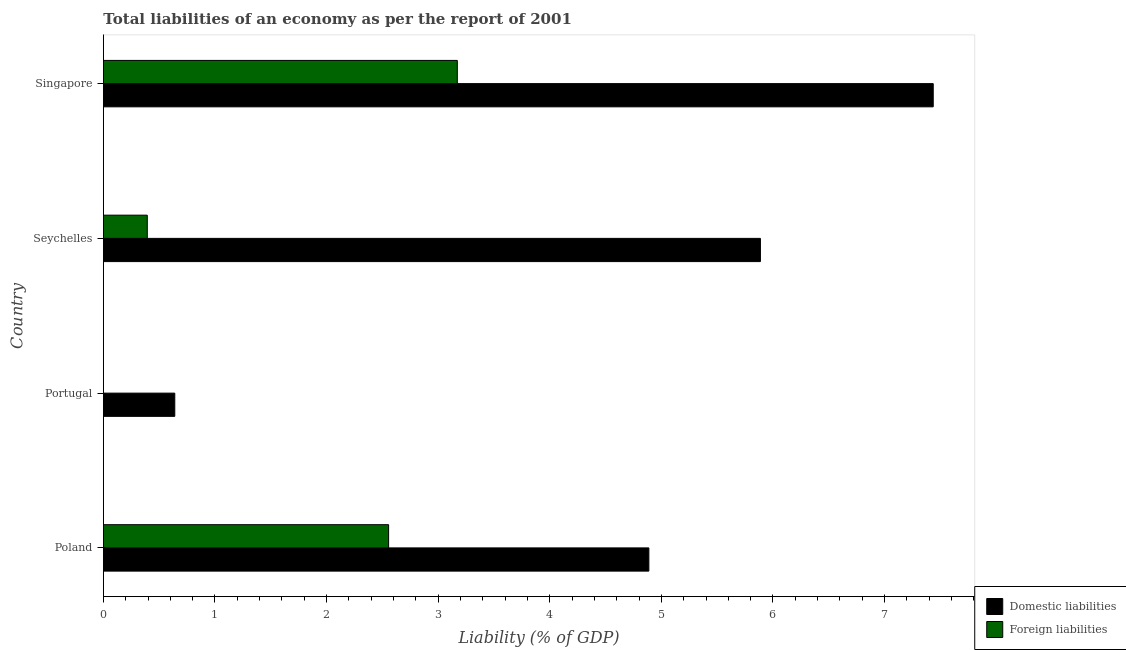How many different coloured bars are there?
Your answer should be compact. 2. How many bars are there on the 2nd tick from the top?
Your answer should be compact. 2. How many bars are there on the 1st tick from the bottom?
Keep it short and to the point. 2. What is the label of the 1st group of bars from the top?
Offer a very short reply. Singapore. What is the incurrence of domestic liabilities in Poland?
Offer a terse response. 4.89. Across all countries, what is the maximum incurrence of foreign liabilities?
Your answer should be compact. 3.17. Across all countries, what is the minimum incurrence of domestic liabilities?
Offer a very short reply. 0.64. In which country was the incurrence of foreign liabilities maximum?
Your answer should be very brief. Singapore. What is the total incurrence of foreign liabilities in the graph?
Make the answer very short. 6.12. What is the difference between the incurrence of domestic liabilities in Portugal and that in Seychelles?
Provide a short and direct response. -5.25. What is the difference between the incurrence of domestic liabilities in Seychelles and the incurrence of foreign liabilities in Portugal?
Your response must be concise. 5.89. What is the average incurrence of foreign liabilities per country?
Make the answer very short. 1.53. What is the difference between the incurrence of domestic liabilities and incurrence of foreign liabilities in Seychelles?
Make the answer very short. 5.49. In how many countries, is the incurrence of domestic liabilities greater than 6 %?
Your response must be concise. 1. What is the ratio of the incurrence of domestic liabilities in Poland to that in Portugal?
Provide a succinct answer. 7.64. Is the difference between the incurrence of foreign liabilities in Poland and Seychelles greater than the difference between the incurrence of domestic liabilities in Poland and Seychelles?
Provide a short and direct response. Yes. What is the difference between the highest and the second highest incurrence of domestic liabilities?
Keep it short and to the point. 1.55. What is the difference between the highest and the lowest incurrence of foreign liabilities?
Provide a short and direct response. 3.17. In how many countries, is the incurrence of foreign liabilities greater than the average incurrence of foreign liabilities taken over all countries?
Your response must be concise. 2. Are the values on the major ticks of X-axis written in scientific E-notation?
Offer a very short reply. No. Does the graph contain any zero values?
Your answer should be compact. Yes. Does the graph contain grids?
Your response must be concise. No. What is the title of the graph?
Your answer should be compact. Total liabilities of an economy as per the report of 2001. What is the label or title of the X-axis?
Provide a succinct answer. Liability (% of GDP). What is the Liability (% of GDP) in Domestic liabilities in Poland?
Your response must be concise. 4.89. What is the Liability (% of GDP) in Foreign liabilities in Poland?
Your answer should be compact. 2.56. What is the Liability (% of GDP) of Domestic liabilities in Portugal?
Provide a succinct answer. 0.64. What is the Liability (% of GDP) of Foreign liabilities in Portugal?
Ensure brevity in your answer.  0. What is the Liability (% of GDP) in Domestic liabilities in Seychelles?
Offer a very short reply. 5.89. What is the Liability (% of GDP) in Foreign liabilities in Seychelles?
Provide a succinct answer. 0.39. What is the Liability (% of GDP) in Domestic liabilities in Singapore?
Ensure brevity in your answer.  7.44. What is the Liability (% of GDP) of Foreign liabilities in Singapore?
Make the answer very short. 3.17. Across all countries, what is the maximum Liability (% of GDP) of Domestic liabilities?
Provide a succinct answer. 7.44. Across all countries, what is the maximum Liability (% of GDP) of Foreign liabilities?
Ensure brevity in your answer.  3.17. Across all countries, what is the minimum Liability (% of GDP) in Domestic liabilities?
Ensure brevity in your answer.  0.64. Across all countries, what is the minimum Liability (% of GDP) in Foreign liabilities?
Your answer should be very brief. 0. What is the total Liability (% of GDP) in Domestic liabilities in the graph?
Provide a succinct answer. 18.85. What is the total Liability (% of GDP) in Foreign liabilities in the graph?
Ensure brevity in your answer.  6.12. What is the difference between the Liability (% of GDP) of Domestic liabilities in Poland and that in Portugal?
Offer a very short reply. 4.25. What is the difference between the Liability (% of GDP) of Domestic liabilities in Poland and that in Seychelles?
Provide a short and direct response. -1. What is the difference between the Liability (% of GDP) in Foreign liabilities in Poland and that in Seychelles?
Your response must be concise. 2.16. What is the difference between the Liability (% of GDP) in Domestic liabilities in Poland and that in Singapore?
Ensure brevity in your answer.  -2.55. What is the difference between the Liability (% of GDP) in Foreign liabilities in Poland and that in Singapore?
Offer a very short reply. -0.62. What is the difference between the Liability (% of GDP) in Domestic liabilities in Portugal and that in Seychelles?
Your response must be concise. -5.25. What is the difference between the Liability (% of GDP) of Domestic liabilities in Portugal and that in Singapore?
Provide a succinct answer. -6.8. What is the difference between the Liability (% of GDP) of Domestic liabilities in Seychelles and that in Singapore?
Offer a very short reply. -1.55. What is the difference between the Liability (% of GDP) of Foreign liabilities in Seychelles and that in Singapore?
Provide a succinct answer. -2.78. What is the difference between the Liability (% of GDP) of Domestic liabilities in Poland and the Liability (% of GDP) of Foreign liabilities in Seychelles?
Make the answer very short. 4.49. What is the difference between the Liability (% of GDP) in Domestic liabilities in Poland and the Liability (% of GDP) in Foreign liabilities in Singapore?
Ensure brevity in your answer.  1.72. What is the difference between the Liability (% of GDP) in Domestic liabilities in Portugal and the Liability (% of GDP) in Foreign liabilities in Seychelles?
Your answer should be very brief. 0.25. What is the difference between the Liability (% of GDP) in Domestic liabilities in Portugal and the Liability (% of GDP) in Foreign liabilities in Singapore?
Offer a very short reply. -2.53. What is the difference between the Liability (% of GDP) in Domestic liabilities in Seychelles and the Liability (% of GDP) in Foreign liabilities in Singapore?
Offer a very short reply. 2.72. What is the average Liability (% of GDP) in Domestic liabilities per country?
Offer a very short reply. 4.71. What is the average Liability (% of GDP) in Foreign liabilities per country?
Offer a terse response. 1.53. What is the difference between the Liability (% of GDP) of Domestic liabilities and Liability (% of GDP) of Foreign liabilities in Poland?
Ensure brevity in your answer.  2.33. What is the difference between the Liability (% of GDP) of Domestic liabilities and Liability (% of GDP) of Foreign liabilities in Seychelles?
Your answer should be compact. 5.49. What is the difference between the Liability (% of GDP) in Domestic liabilities and Liability (% of GDP) in Foreign liabilities in Singapore?
Your answer should be very brief. 4.26. What is the ratio of the Liability (% of GDP) in Domestic liabilities in Poland to that in Portugal?
Offer a very short reply. 7.64. What is the ratio of the Liability (% of GDP) in Domestic liabilities in Poland to that in Seychelles?
Offer a very short reply. 0.83. What is the ratio of the Liability (% of GDP) of Foreign liabilities in Poland to that in Seychelles?
Your answer should be very brief. 6.5. What is the ratio of the Liability (% of GDP) of Domestic liabilities in Poland to that in Singapore?
Keep it short and to the point. 0.66. What is the ratio of the Liability (% of GDP) of Foreign liabilities in Poland to that in Singapore?
Offer a very short reply. 0.81. What is the ratio of the Liability (% of GDP) in Domestic liabilities in Portugal to that in Seychelles?
Your answer should be very brief. 0.11. What is the ratio of the Liability (% of GDP) in Domestic liabilities in Portugal to that in Singapore?
Ensure brevity in your answer.  0.09. What is the ratio of the Liability (% of GDP) of Domestic liabilities in Seychelles to that in Singapore?
Make the answer very short. 0.79. What is the ratio of the Liability (% of GDP) of Foreign liabilities in Seychelles to that in Singapore?
Ensure brevity in your answer.  0.12. What is the difference between the highest and the second highest Liability (% of GDP) in Domestic liabilities?
Give a very brief answer. 1.55. What is the difference between the highest and the second highest Liability (% of GDP) in Foreign liabilities?
Make the answer very short. 0.62. What is the difference between the highest and the lowest Liability (% of GDP) of Domestic liabilities?
Provide a succinct answer. 6.8. What is the difference between the highest and the lowest Liability (% of GDP) of Foreign liabilities?
Give a very brief answer. 3.17. 